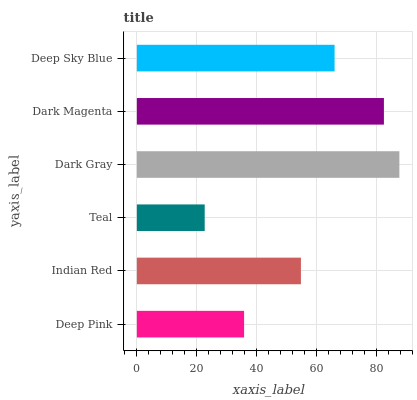Is Teal the minimum?
Answer yes or no. Yes. Is Dark Gray the maximum?
Answer yes or no. Yes. Is Indian Red the minimum?
Answer yes or no. No. Is Indian Red the maximum?
Answer yes or no. No. Is Indian Red greater than Deep Pink?
Answer yes or no. Yes. Is Deep Pink less than Indian Red?
Answer yes or no. Yes. Is Deep Pink greater than Indian Red?
Answer yes or no. No. Is Indian Red less than Deep Pink?
Answer yes or no. No. Is Deep Sky Blue the high median?
Answer yes or no. Yes. Is Indian Red the low median?
Answer yes or no. Yes. Is Dark Gray the high median?
Answer yes or no. No. Is Deep Pink the low median?
Answer yes or no. No. 